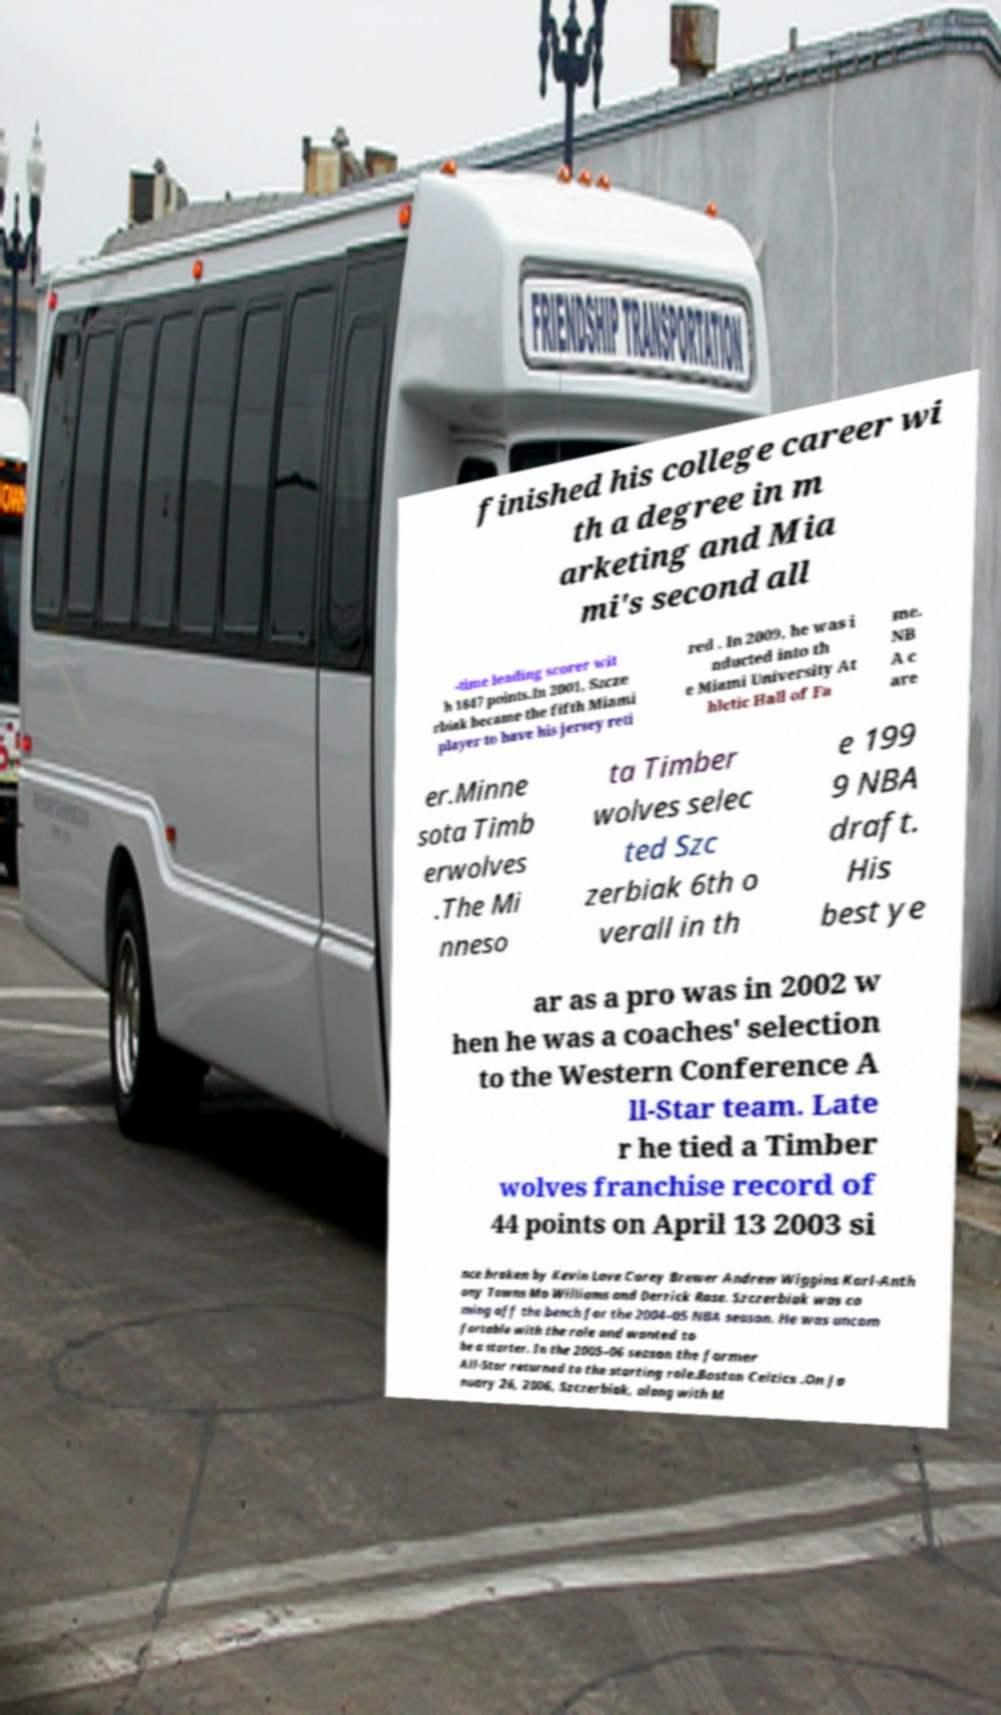There's text embedded in this image that I need extracted. Can you transcribe it verbatim? finished his college career wi th a degree in m arketing and Mia mi's second all -time leading scorer wit h 1847 points.In 2001, Szcze rbiak became the fifth Miami player to have his jersey reti red . In 2009, he was i nducted into th e Miami University At hletic Hall of Fa me. NB A c are er.Minne sota Timb erwolves .The Mi nneso ta Timber wolves selec ted Szc zerbiak 6th o verall in th e 199 9 NBA draft. His best ye ar as a pro was in 2002 w hen he was a coaches' selection to the Western Conference A ll-Star team. Late r he tied a Timber wolves franchise record of 44 points on April 13 2003 si nce broken by Kevin Love Corey Brewer Andrew Wiggins Karl-Anth ony Towns Mo Williams and Derrick Rose. Szczerbiak was co ming off the bench for the 2004–05 NBA season. He was uncom fortable with the role and wanted to be a starter. In the 2005–06 season the former All-Star returned to the starting role.Boston Celtics .On Ja nuary 26, 2006, Szczerbiak, along with M 